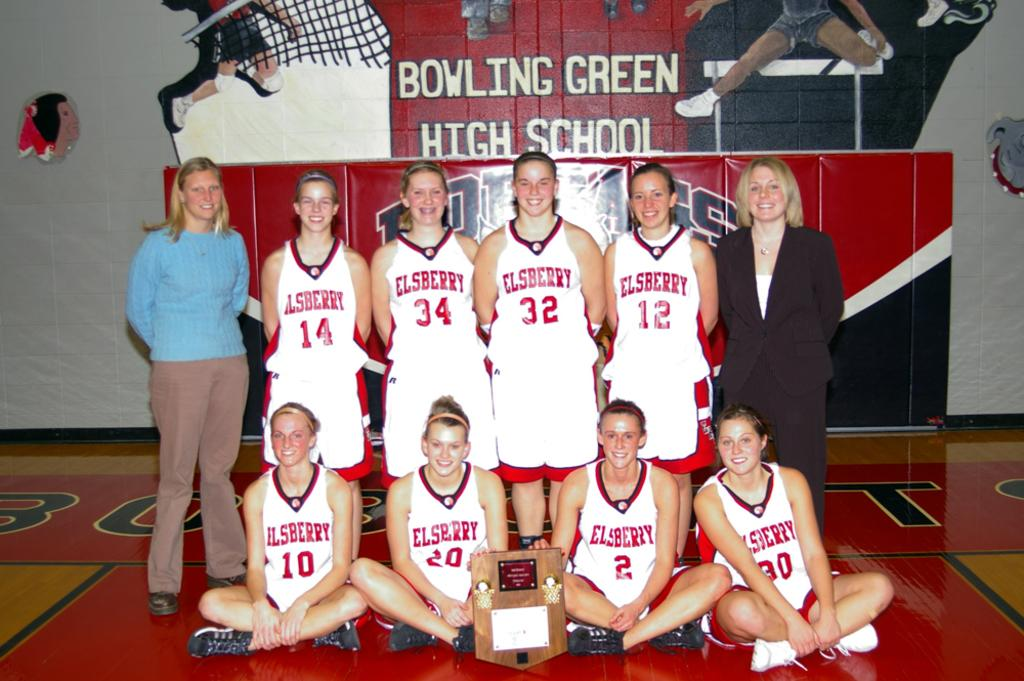<image>
Share a concise interpretation of the image provided. a group of students with Elsberry school on their jerseys 